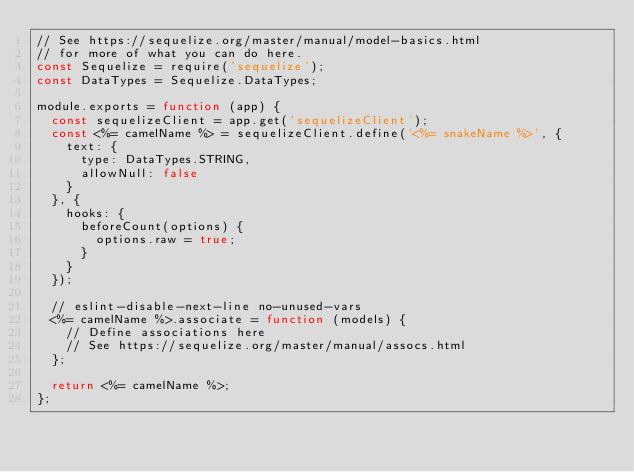<code> <loc_0><loc_0><loc_500><loc_500><_JavaScript_>// See https://sequelize.org/master/manual/model-basics.html
// for more of what you can do here.
const Sequelize = require('sequelize');
const DataTypes = Sequelize.DataTypes;

module.exports = function (app) {
  const sequelizeClient = app.get('sequelizeClient');
  const <%= camelName %> = sequelizeClient.define('<%= snakeName %>', {
    text: {
      type: DataTypes.STRING,
      allowNull: false
    }
  }, {
    hooks: {
      beforeCount(options) {
        options.raw = true;
      }
    }
  });

  // eslint-disable-next-line no-unused-vars
  <%= camelName %>.associate = function (models) {
    // Define associations here
    // See https://sequelize.org/master/manual/assocs.html
  };

  return <%= camelName %>;
};
</code> 